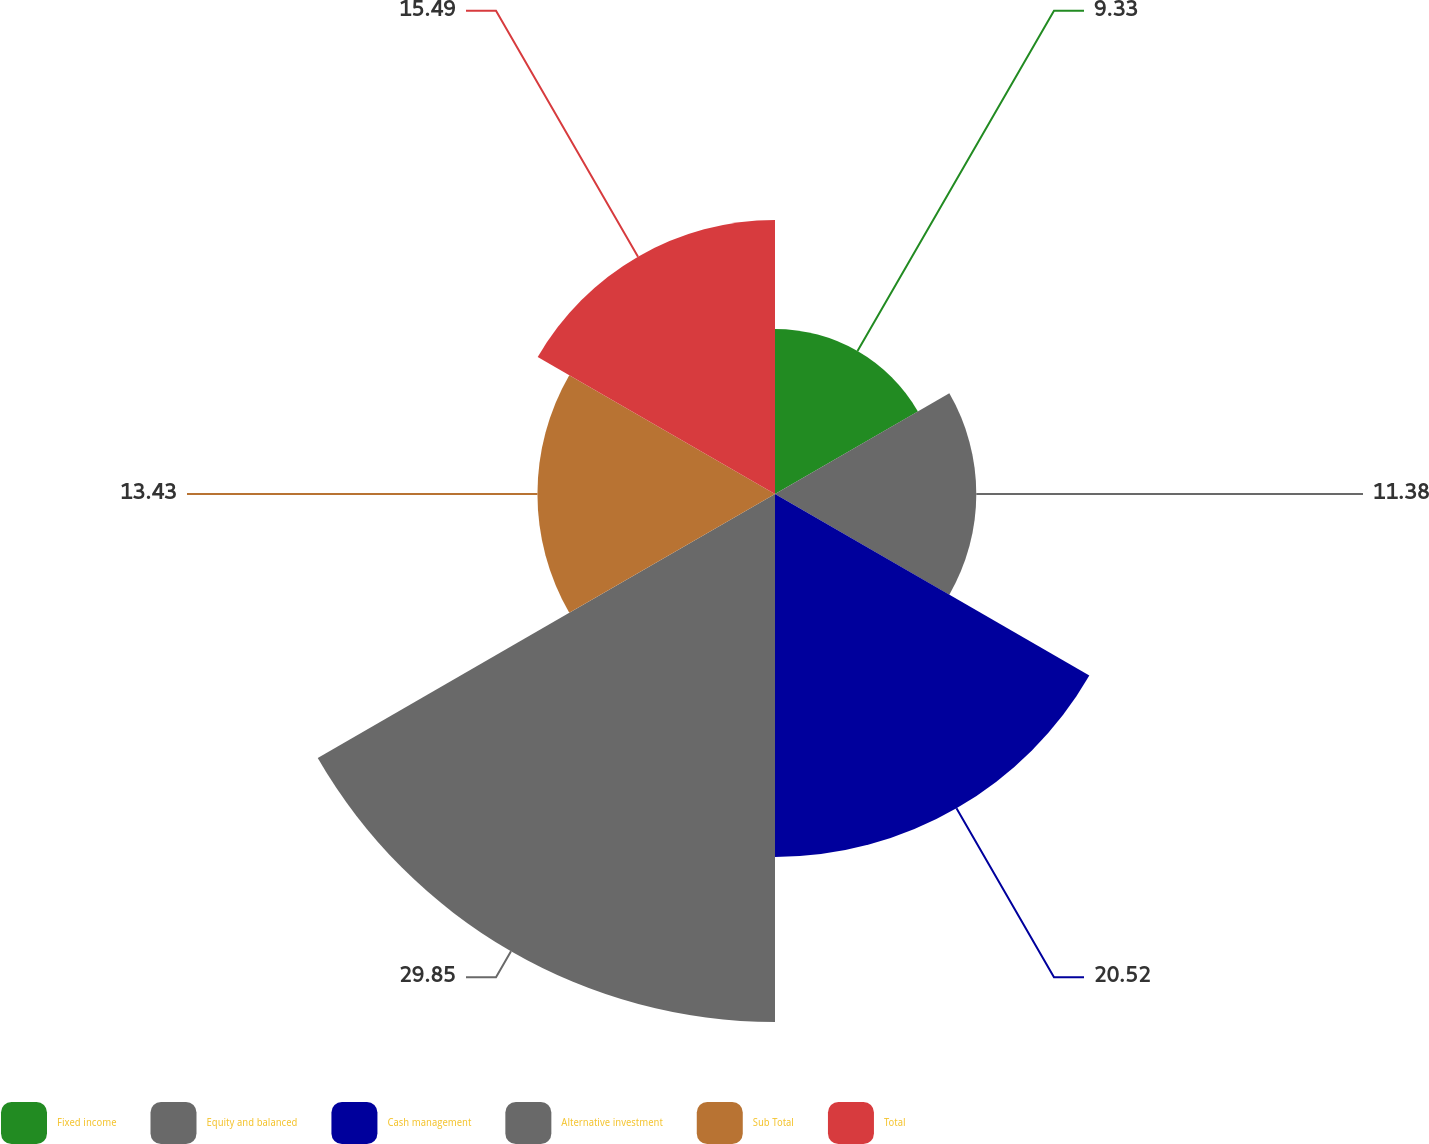Convert chart to OTSL. <chart><loc_0><loc_0><loc_500><loc_500><pie_chart><fcel>Fixed income<fcel>Equity and balanced<fcel>Cash management<fcel>Alternative investment<fcel>Sub Total<fcel>Total<nl><fcel>9.33%<fcel>11.38%<fcel>20.52%<fcel>29.85%<fcel>13.43%<fcel>15.49%<nl></chart> 